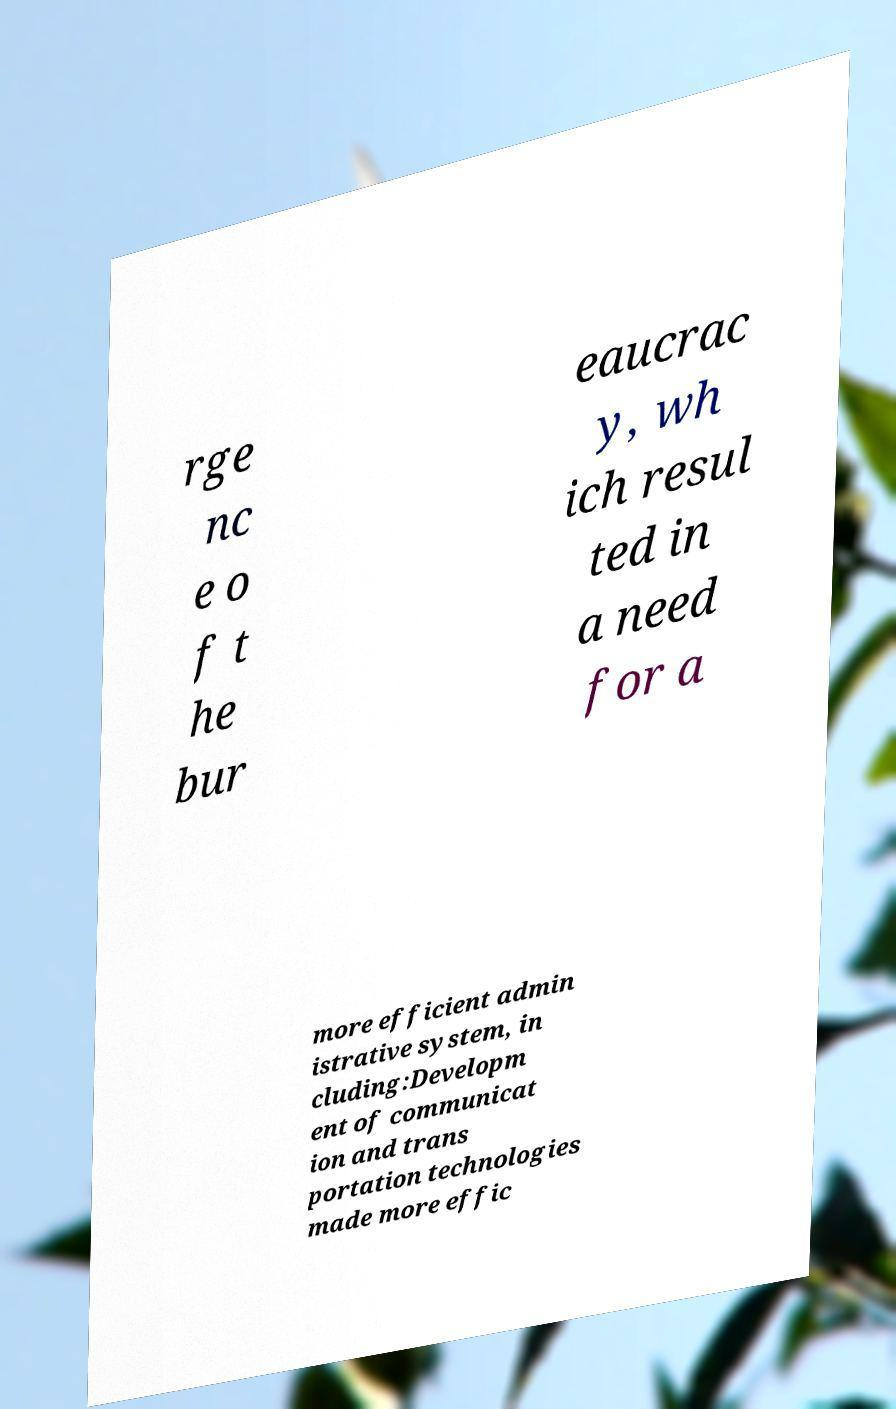Can you read and provide the text displayed in the image?This photo seems to have some interesting text. Can you extract and type it out for me? rge nc e o f t he bur eaucrac y, wh ich resul ted in a need for a more efficient admin istrative system, in cluding:Developm ent of communicat ion and trans portation technologies made more effic 